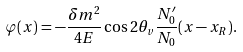Convert formula to latex. <formula><loc_0><loc_0><loc_500><loc_500>\varphi ( x ) = - \frac { \delta m ^ { 2 } } { 4 E } \cos { 2 \theta _ { v } } \frac { N _ { 0 } ^ { \prime } } { N _ { 0 } } ( x - x _ { R } ) .</formula> 